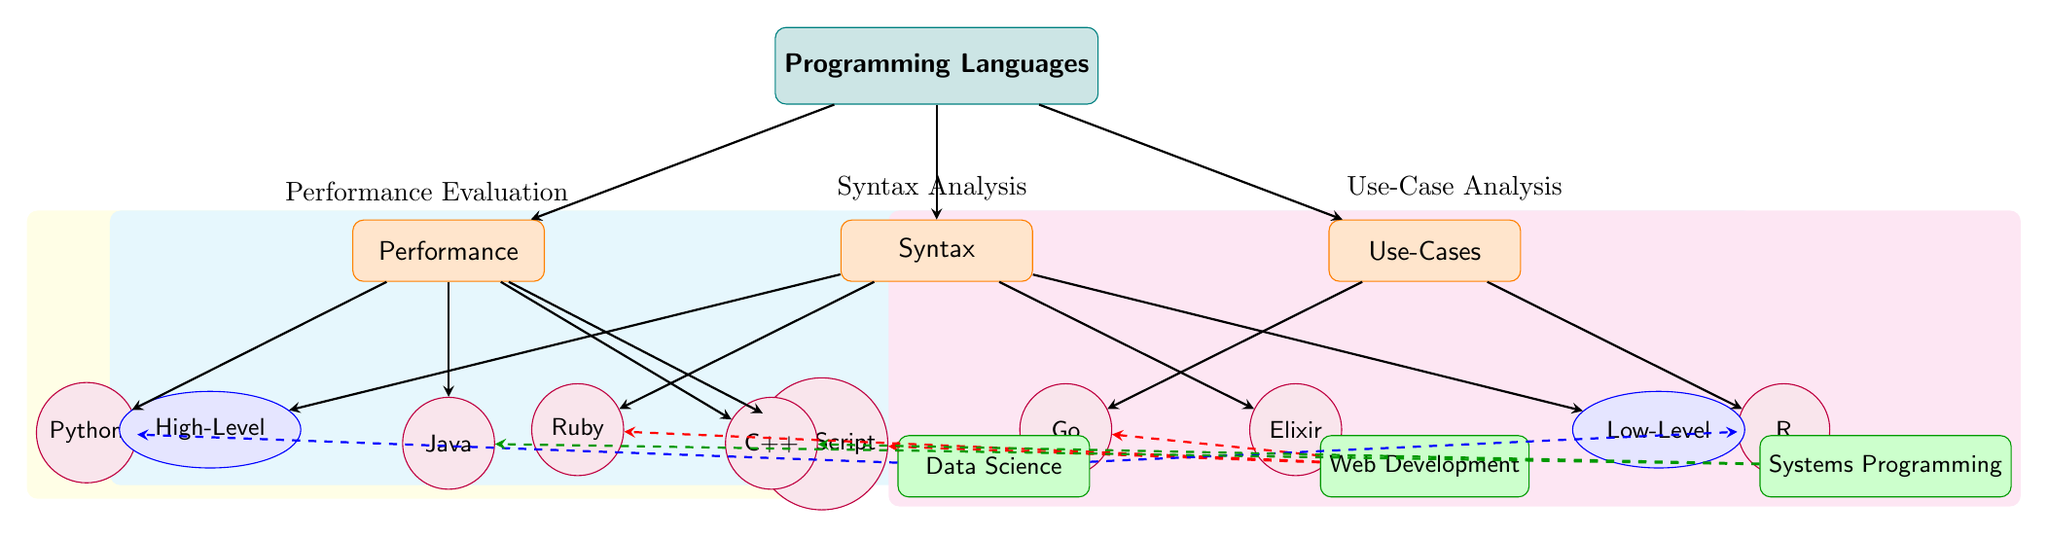What are the three main criteria for evaluating programming languages? The diagram specifies three main criteria: Performance, Syntax, and Use-Cases, which are presented as separate nodes directly connected to the main category of Programming Languages.
Answer: Performance, Syntax, Use-Cases Which programming language is categorized under Performance alongside Java? The diagram lists Python and Java under the Performance criterion. Since Java is already named, the next language in that category is Python.
Answer: Python How many programming languages are listed under the Use-Cases section? The Use-Cases section features two programming languages, Go and R, as shown directly there, making the count straightforward.
Answer: 2 Which programming language falls under the Low-Level subcriteria? The Low-Level subcriteria is indicated to the right of the language category, leading to Elixir, so Elixir is the programming language categorized here.
Answer: Elixir Which programming languages are associated with Web Development according to the diagram? Web Development connects to three programming languages, which are JavaScript, Ruby, and Go. By reviewing the dashed connections specifically indicated for Web Development, we find these three languages.
Answer: JavaScript, Ruby, Go What is the relationship between Python and Data Science in the diagram? The diagram shows a dashed blue arrow leading from Data Science to Python, indicating a direct association or usage of Python within the context of Data Science.
Answer: Association Which programming language is not linked to Syntax Analysis in the diagram? From the Syntax Analysis section, Ruby and Elixir both have arrows leading to them indicating connections, so the programming language Go does not have any association with Syntax Analysis.
Answer: Go How many languages are listed under the Performance Evaluation background section? The Performance Evaluation section has a yellow background covering four programming languages: Python, Java, JavaScript, and C++. Counting all of these reveals the total.
Answer: 4 Which programming language is commonly used for Systems Programming? The diagram identifies two programming languages linked to Systems Programming, which are Java and C++. Therefore, both languages share this association.
Answer: Java, C++ 